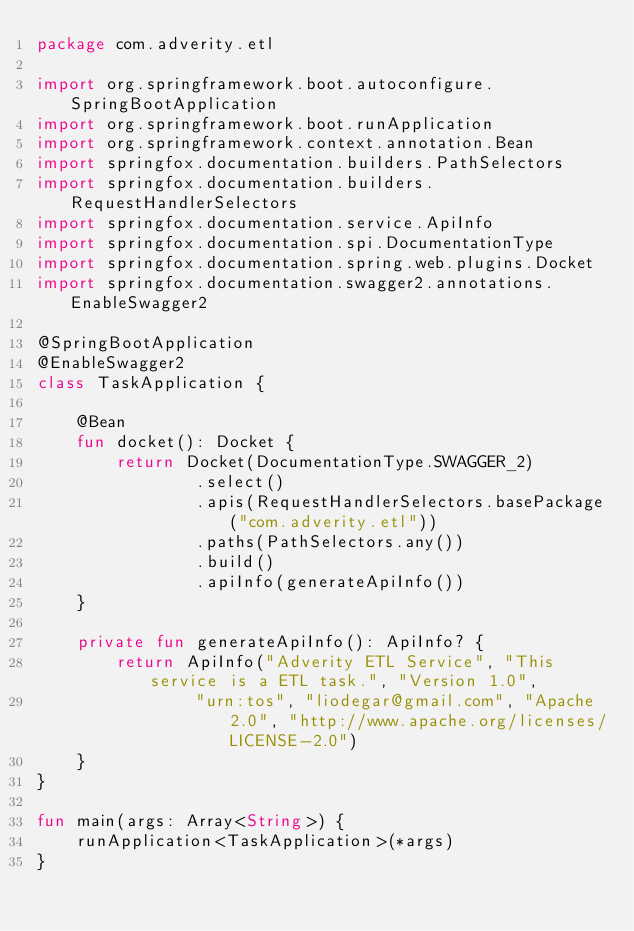Convert code to text. <code><loc_0><loc_0><loc_500><loc_500><_Kotlin_>package com.adverity.etl

import org.springframework.boot.autoconfigure.SpringBootApplication
import org.springframework.boot.runApplication
import org.springframework.context.annotation.Bean
import springfox.documentation.builders.PathSelectors
import springfox.documentation.builders.RequestHandlerSelectors
import springfox.documentation.service.ApiInfo
import springfox.documentation.spi.DocumentationType
import springfox.documentation.spring.web.plugins.Docket
import springfox.documentation.swagger2.annotations.EnableSwagger2

@SpringBootApplication
@EnableSwagger2
class TaskApplication {

    @Bean
    fun docket(): Docket {
        return Docket(DocumentationType.SWAGGER_2)
                .select()
                .apis(RequestHandlerSelectors.basePackage("com.adverity.etl"))
                .paths(PathSelectors.any())
                .build()
                .apiInfo(generateApiInfo())
    }

    private fun generateApiInfo(): ApiInfo? {
        return ApiInfo("Adverity ETL Service", "This service is a ETL task.", "Version 1.0",
                "urn:tos", "liodegar@gmail.com", "Apache 2.0", "http://www.apache.org/licenses/LICENSE-2.0")
    }
}

fun main(args: Array<String>) {
    runApplication<TaskApplication>(*args)
}


</code> 